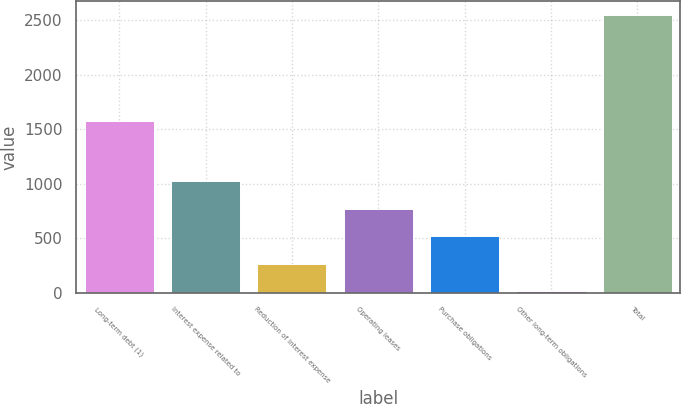<chart> <loc_0><loc_0><loc_500><loc_500><bar_chart><fcel>Long-term debt (1)<fcel>Interest expense related to<fcel>Reduction of interest expense<fcel>Operating leases<fcel>Purchase obligations<fcel>Other long-term obligations<fcel>Total<nl><fcel>1576<fcel>1027.2<fcel>265.8<fcel>773.4<fcel>519.6<fcel>12<fcel>2550<nl></chart> 